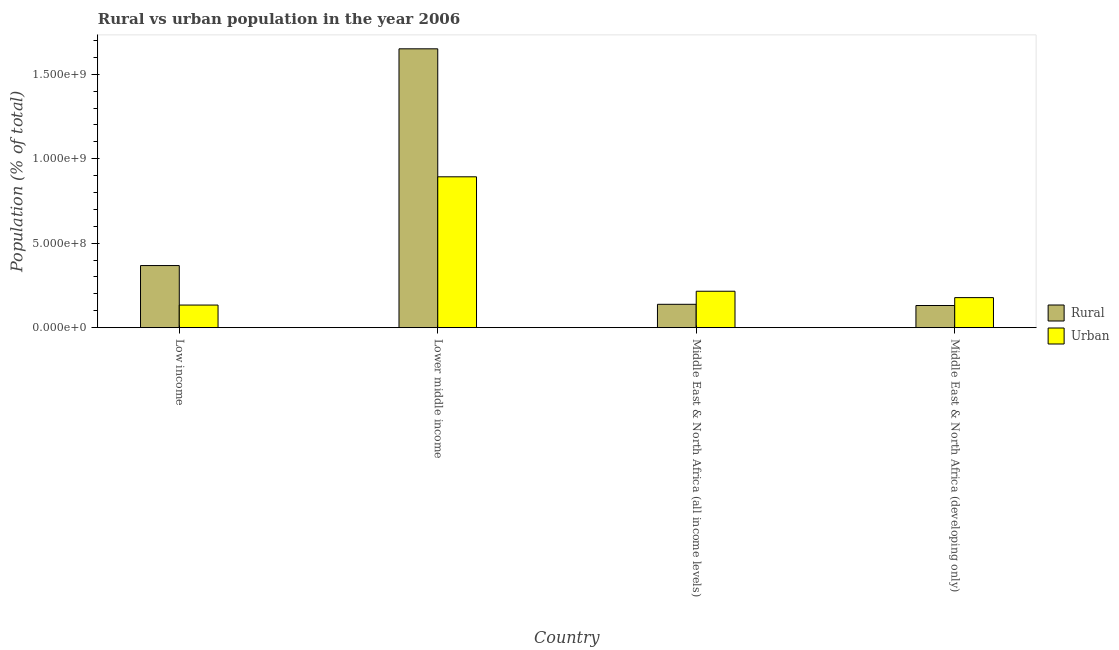How many different coloured bars are there?
Keep it short and to the point. 2. How many groups of bars are there?
Your answer should be very brief. 4. Are the number of bars per tick equal to the number of legend labels?
Keep it short and to the point. Yes. Are the number of bars on each tick of the X-axis equal?
Provide a succinct answer. Yes. How many bars are there on the 1st tick from the left?
Give a very brief answer. 2. In how many cases, is the number of bars for a given country not equal to the number of legend labels?
Provide a short and direct response. 0. What is the urban population density in Lower middle income?
Offer a very short reply. 8.93e+08. Across all countries, what is the maximum urban population density?
Your answer should be compact. 8.93e+08. Across all countries, what is the minimum urban population density?
Provide a short and direct response. 1.34e+08. In which country was the rural population density maximum?
Make the answer very short. Lower middle income. In which country was the rural population density minimum?
Your answer should be compact. Middle East & North Africa (developing only). What is the total urban population density in the graph?
Offer a terse response. 1.42e+09. What is the difference between the urban population density in Lower middle income and that in Middle East & North Africa (developing only)?
Your answer should be compact. 7.15e+08. What is the difference between the urban population density in Middle East & North Africa (developing only) and the rural population density in Middle East & North Africa (all income levels)?
Your answer should be compact. 3.95e+07. What is the average rural population density per country?
Provide a succinct answer. 5.72e+08. What is the difference between the urban population density and rural population density in Middle East & North Africa (all income levels)?
Give a very brief answer. 7.73e+07. In how many countries, is the urban population density greater than 800000000 %?
Provide a succinct answer. 1. What is the ratio of the urban population density in Low income to that in Lower middle income?
Provide a succinct answer. 0.15. What is the difference between the highest and the second highest urban population density?
Your response must be concise. 6.77e+08. What is the difference between the highest and the lowest urban population density?
Your answer should be very brief. 7.59e+08. In how many countries, is the urban population density greater than the average urban population density taken over all countries?
Make the answer very short. 1. What does the 2nd bar from the left in Lower middle income represents?
Offer a terse response. Urban. What does the 2nd bar from the right in Middle East & North Africa (all income levels) represents?
Offer a terse response. Rural. How many bars are there?
Provide a succinct answer. 8. Are all the bars in the graph horizontal?
Provide a short and direct response. No. How many countries are there in the graph?
Offer a very short reply. 4. What is the difference between two consecutive major ticks on the Y-axis?
Your answer should be very brief. 5.00e+08. Does the graph contain any zero values?
Your response must be concise. No. Where does the legend appear in the graph?
Provide a short and direct response. Center right. How are the legend labels stacked?
Offer a very short reply. Vertical. What is the title of the graph?
Provide a succinct answer. Rural vs urban population in the year 2006. Does "Tetanus" appear as one of the legend labels in the graph?
Make the answer very short. No. What is the label or title of the Y-axis?
Provide a succinct answer. Population (% of total). What is the Population (% of total) of Rural in Low income?
Ensure brevity in your answer.  3.68e+08. What is the Population (% of total) in Urban in Low income?
Ensure brevity in your answer.  1.34e+08. What is the Population (% of total) in Rural in Lower middle income?
Provide a short and direct response. 1.65e+09. What is the Population (% of total) of Urban in Lower middle income?
Your response must be concise. 8.93e+08. What is the Population (% of total) in Rural in Middle East & North Africa (all income levels)?
Your answer should be compact. 1.38e+08. What is the Population (% of total) in Urban in Middle East & North Africa (all income levels)?
Your answer should be very brief. 2.16e+08. What is the Population (% of total) of Rural in Middle East & North Africa (developing only)?
Ensure brevity in your answer.  1.31e+08. What is the Population (% of total) of Urban in Middle East & North Africa (developing only)?
Give a very brief answer. 1.78e+08. Across all countries, what is the maximum Population (% of total) of Rural?
Make the answer very short. 1.65e+09. Across all countries, what is the maximum Population (% of total) of Urban?
Your answer should be compact. 8.93e+08. Across all countries, what is the minimum Population (% of total) in Rural?
Give a very brief answer. 1.31e+08. Across all countries, what is the minimum Population (% of total) in Urban?
Provide a short and direct response. 1.34e+08. What is the total Population (% of total) of Rural in the graph?
Your answer should be very brief. 2.29e+09. What is the total Population (% of total) in Urban in the graph?
Make the answer very short. 1.42e+09. What is the difference between the Population (% of total) of Rural in Low income and that in Lower middle income?
Provide a succinct answer. -1.28e+09. What is the difference between the Population (% of total) of Urban in Low income and that in Lower middle income?
Your answer should be very brief. -7.59e+08. What is the difference between the Population (% of total) in Rural in Low income and that in Middle East & North Africa (all income levels)?
Keep it short and to the point. 2.29e+08. What is the difference between the Population (% of total) in Urban in Low income and that in Middle East & North Africa (all income levels)?
Provide a succinct answer. -8.18e+07. What is the difference between the Population (% of total) of Rural in Low income and that in Middle East & North Africa (developing only)?
Provide a succinct answer. 2.37e+08. What is the difference between the Population (% of total) of Urban in Low income and that in Middle East & North Africa (developing only)?
Your response must be concise. -4.40e+07. What is the difference between the Population (% of total) of Rural in Lower middle income and that in Middle East & North Africa (all income levels)?
Provide a succinct answer. 1.51e+09. What is the difference between the Population (% of total) in Urban in Lower middle income and that in Middle East & North Africa (all income levels)?
Give a very brief answer. 6.77e+08. What is the difference between the Population (% of total) of Rural in Lower middle income and that in Middle East & North Africa (developing only)?
Ensure brevity in your answer.  1.52e+09. What is the difference between the Population (% of total) in Urban in Lower middle income and that in Middle East & North Africa (developing only)?
Your response must be concise. 7.15e+08. What is the difference between the Population (% of total) of Rural in Middle East & North Africa (all income levels) and that in Middle East & North Africa (developing only)?
Ensure brevity in your answer.  7.16e+06. What is the difference between the Population (% of total) of Urban in Middle East & North Africa (all income levels) and that in Middle East & North Africa (developing only)?
Offer a very short reply. 3.78e+07. What is the difference between the Population (% of total) of Rural in Low income and the Population (% of total) of Urban in Lower middle income?
Provide a short and direct response. -5.25e+08. What is the difference between the Population (% of total) in Rural in Low income and the Population (% of total) in Urban in Middle East & North Africa (all income levels)?
Provide a succinct answer. 1.52e+08. What is the difference between the Population (% of total) in Rural in Low income and the Population (% of total) in Urban in Middle East & North Africa (developing only)?
Your answer should be very brief. 1.90e+08. What is the difference between the Population (% of total) in Rural in Lower middle income and the Population (% of total) in Urban in Middle East & North Africa (all income levels)?
Your answer should be compact. 1.44e+09. What is the difference between the Population (% of total) in Rural in Lower middle income and the Population (% of total) in Urban in Middle East & North Africa (developing only)?
Offer a terse response. 1.47e+09. What is the difference between the Population (% of total) of Rural in Middle East & North Africa (all income levels) and the Population (% of total) of Urban in Middle East & North Africa (developing only)?
Your answer should be compact. -3.95e+07. What is the average Population (% of total) in Rural per country?
Your answer should be compact. 5.72e+08. What is the average Population (% of total) in Urban per country?
Offer a terse response. 3.55e+08. What is the difference between the Population (% of total) of Rural and Population (% of total) of Urban in Low income?
Provide a short and direct response. 2.34e+08. What is the difference between the Population (% of total) of Rural and Population (% of total) of Urban in Lower middle income?
Provide a succinct answer. 7.58e+08. What is the difference between the Population (% of total) in Rural and Population (% of total) in Urban in Middle East & North Africa (all income levels)?
Make the answer very short. -7.73e+07. What is the difference between the Population (% of total) of Rural and Population (% of total) of Urban in Middle East & North Africa (developing only)?
Provide a succinct answer. -4.67e+07. What is the ratio of the Population (% of total) of Rural in Low income to that in Lower middle income?
Make the answer very short. 0.22. What is the ratio of the Population (% of total) of Urban in Low income to that in Lower middle income?
Keep it short and to the point. 0.15. What is the ratio of the Population (% of total) in Rural in Low income to that in Middle East & North Africa (all income levels)?
Your answer should be compact. 2.66. What is the ratio of the Population (% of total) of Urban in Low income to that in Middle East & North Africa (all income levels)?
Give a very brief answer. 0.62. What is the ratio of the Population (% of total) in Rural in Low income to that in Middle East & North Africa (developing only)?
Provide a succinct answer. 2.8. What is the ratio of the Population (% of total) of Urban in Low income to that in Middle East & North Africa (developing only)?
Your answer should be compact. 0.75. What is the ratio of the Population (% of total) in Rural in Lower middle income to that in Middle East & North Africa (all income levels)?
Your answer should be very brief. 11.94. What is the ratio of the Population (% of total) of Urban in Lower middle income to that in Middle East & North Africa (all income levels)?
Provide a short and direct response. 4.14. What is the ratio of the Population (% of total) of Rural in Lower middle income to that in Middle East & North Africa (developing only)?
Offer a terse response. 12.59. What is the ratio of the Population (% of total) of Urban in Lower middle income to that in Middle East & North Africa (developing only)?
Your answer should be very brief. 5.02. What is the ratio of the Population (% of total) of Rural in Middle East & North Africa (all income levels) to that in Middle East & North Africa (developing only)?
Make the answer very short. 1.05. What is the ratio of the Population (% of total) of Urban in Middle East & North Africa (all income levels) to that in Middle East & North Africa (developing only)?
Provide a short and direct response. 1.21. What is the difference between the highest and the second highest Population (% of total) of Rural?
Give a very brief answer. 1.28e+09. What is the difference between the highest and the second highest Population (% of total) in Urban?
Your response must be concise. 6.77e+08. What is the difference between the highest and the lowest Population (% of total) of Rural?
Provide a succinct answer. 1.52e+09. What is the difference between the highest and the lowest Population (% of total) in Urban?
Provide a short and direct response. 7.59e+08. 